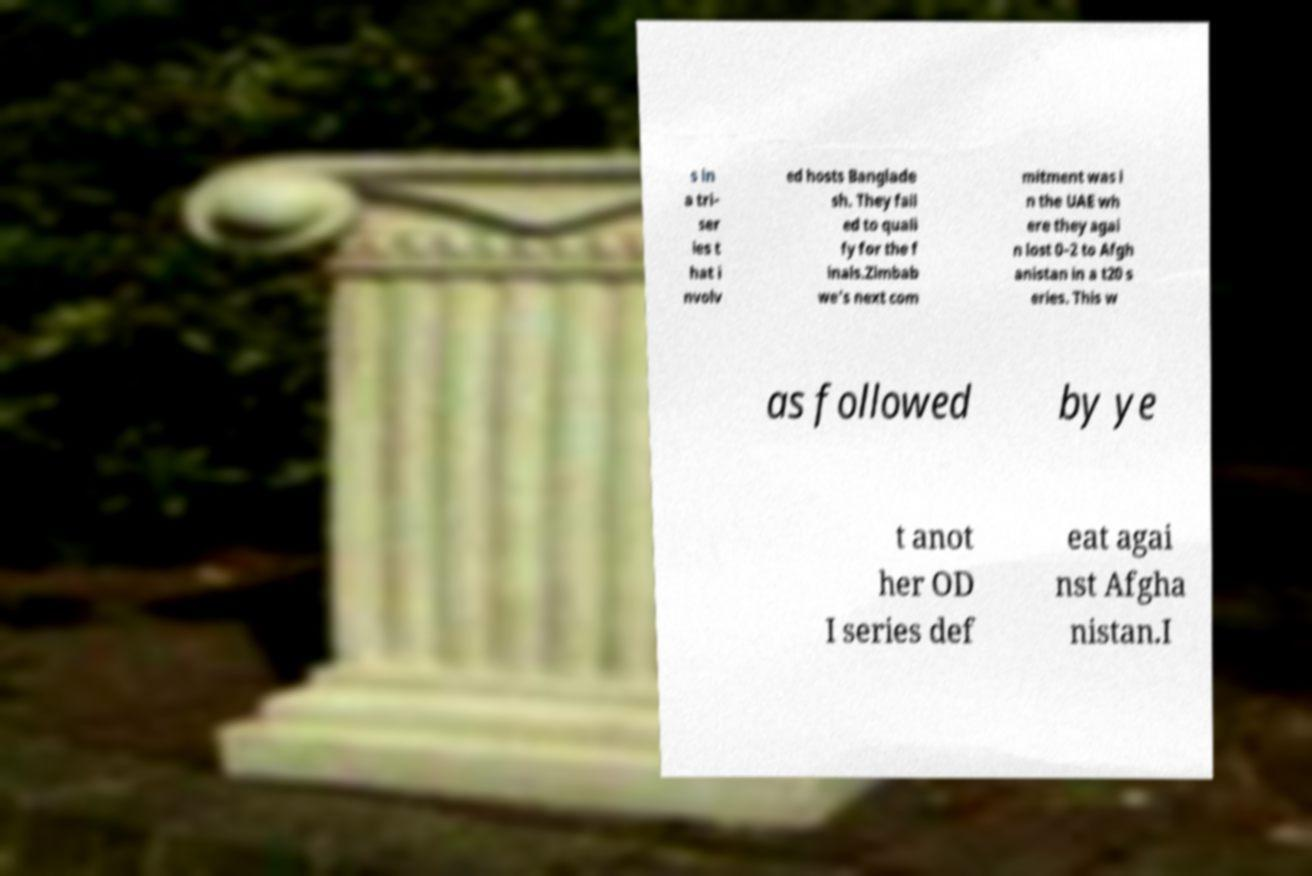Can you accurately transcribe the text from the provided image for me? s in a tri- ser ies t hat i nvolv ed hosts Banglade sh. They fail ed to quali fy for the f inals.Zimbab we's next com mitment was i n the UAE wh ere they agai n lost 0–2 to Afgh anistan in a t20 s eries. This w as followed by ye t anot her OD I series def eat agai nst Afgha nistan.I 